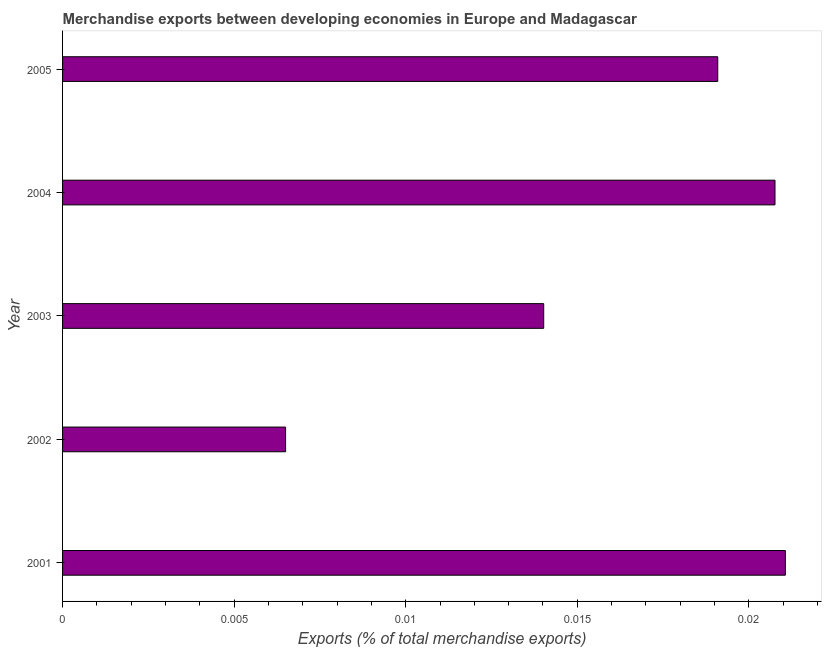Does the graph contain any zero values?
Keep it short and to the point. No. Does the graph contain grids?
Offer a very short reply. No. What is the title of the graph?
Provide a succinct answer. Merchandise exports between developing economies in Europe and Madagascar. What is the label or title of the X-axis?
Give a very brief answer. Exports (% of total merchandise exports). What is the merchandise exports in 2001?
Offer a very short reply. 0.02. Across all years, what is the maximum merchandise exports?
Your answer should be compact. 0.02. Across all years, what is the minimum merchandise exports?
Ensure brevity in your answer.  0.01. In which year was the merchandise exports maximum?
Offer a very short reply. 2001. In which year was the merchandise exports minimum?
Ensure brevity in your answer.  2002. What is the sum of the merchandise exports?
Keep it short and to the point. 0.08. What is the difference between the merchandise exports in 2002 and 2004?
Your response must be concise. -0.01. What is the average merchandise exports per year?
Your answer should be very brief. 0.02. What is the median merchandise exports?
Your answer should be compact. 0.02. Do a majority of the years between 2002 and 2005 (inclusive) have merchandise exports greater than 0.01 %?
Keep it short and to the point. Yes. What is the ratio of the merchandise exports in 2002 to that in 2004?
Keep it short and to the point. 0.31. Is the merchandise exports in 2002 less than that in 2005?
Ensure brevity in your answer.  Yes. What is the difference between the highest and the second highest merchandise exports?
Provide a succinct answer. 0. Is the sum of the merchandise exports in 2002 and 2005 greater than the maximum merchandise exports across all years?
Provide a short and direct response. Yes. In how many years, is the merchandise exports greater than the average merchandise exports taken over all years?
Provide a succinct answer. 3. How many years are there in the graph?
Make the answer very short. 5. What is the difference between two consecutive major ticks on the X-axis?
Make the answer very short. 0.01. What is the Exports (% of total merchandise exports) of 2001?
Offer a very short reply. 0.02. What is the Exports (% of total merchandise exports) of 2002?
Make the answer very short. 0.01. What is the Exports (% of total merchandise exports) in 2003?
Your response must be concise. 0.01. What is the Exports (% of total merchandise exports) in 2004?
Keep it short and to the point. 0.02. What is the Exports (% of total merchandise exports) of 2005?
Your answer should be compact. 0.02. What is the difference between the Exports (% of total merchandise exports) in 2001 and 2002?
Your response must be concise. 0.01. What is the difference between the Exports (% of total merchandise exports) in 2001 and 2003?
Make the answer very short. 0.01. What is the difference between the Exports (% of total merchandise exports) in 2001 and 2005?
Your answer should be very brief. 0. What is the difference between the Exports (% of total merchandise exports) in 2002 and 2003?
Offer a very short reply. -0.01. What is the difference between the Exports (% of total merchandise exports) in 2002 and 2004?
Keep it short and to the point. -0.01. What is the difference between the Exports (% of total merchandise exports) in 2002 and 2005?
Provide a short and direct response. -0.01. What is the difference between the Exports (% of total merchandise exports) in 2003 and 2004?
Your answer should be very brief. -0.01. What is the difference between the Exports (% of total merchandise exports) in 2003 and 2005?
Ensure brevity in your answer.  -0.01. What is the difference between the Exports (% of total merchandise exports) in 2004 and 2005?
Your answer should be very brief. 0. What is the ratio of the Exports (% of total merchandise exports) in 2001 to that in 2002?
Offer a terse response. 3.24. What is the ratio of the Exports (% of total merchandise exports) in 2001 to that in 2003?
Provide a short and direct response. 1.5. What is the ratio of the Exports (% of total merchandise exports) in 2001 to that in 2004?
Provide a succinct answer. 1.01. What is the ratio of the Exports (% of total merchandise exports) in 2001 to that in 2005?
Provide a succinct answer. 1.1. What is the ratio of the Exports (% of total merchandise exports) in 2002 to that in 2003?
Provide a succinct answer. 0.46. What is the ratio of the Exports (% of total merchandise exports) in 2002 to that in 2004?
Your answer should be compact. 0.31. What is the ratio of the Exports (% of total merchandise exports) in 2002 to that in 2005?
Your answer should be very brief. 0.34. What is the ratio of the Exports (% of total merchandise exports) in 2003 to that in 2004?
Provide a short and direct response. 0.68. What is the ratio of the Exports (% of total merchandise exports) in 2003 to that in 2005?
Your answer should be very brief. 0.73. What is the ratio of the Exports (% of total merchandise exports) in 2004 to that in 2005?
Offer a very short reply. 1.09. 